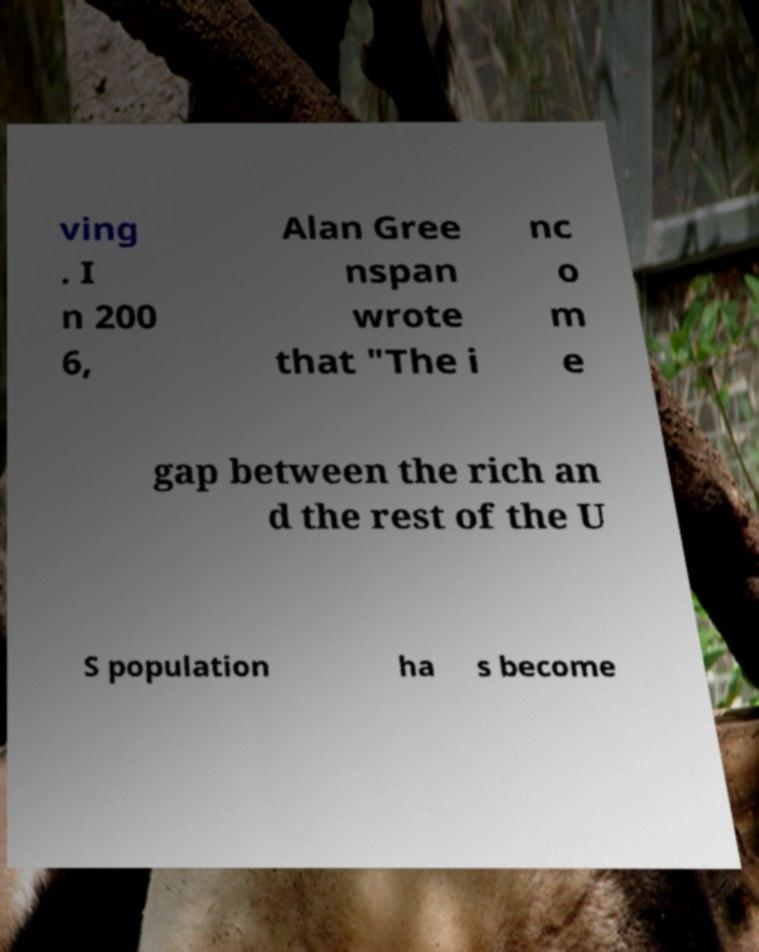Could you assist in decoding the text presented in this image and type it out clearly? ving . I n 200 6, Alan Gree nspan wrote that "The i nc o m e gap between the rich an d the rest of the U S population ha s become 